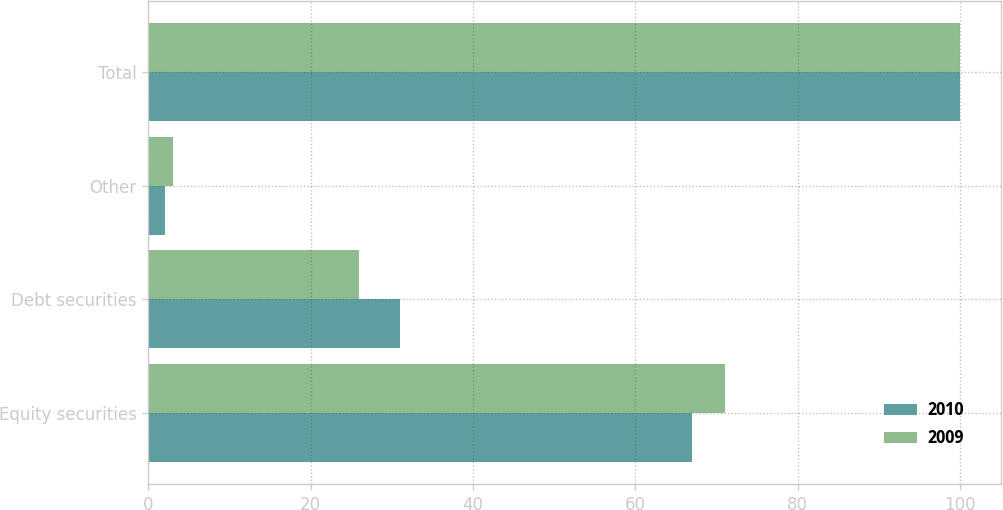Convert chart to OTSL. <chart><loc_0><loc_0><loc_500><loc_500><stacked_bar_chart><ecel><fcel>Equity securities<fcel>Debt securities<fcel>Other<fcel>Total<nl><fcel>2010<fcel>67<fcel>31<fcel>2<fcel>100<nl><fcel>2009<fcel>71<fcel>26<fcel>3<fcel>100<nl></chart> 